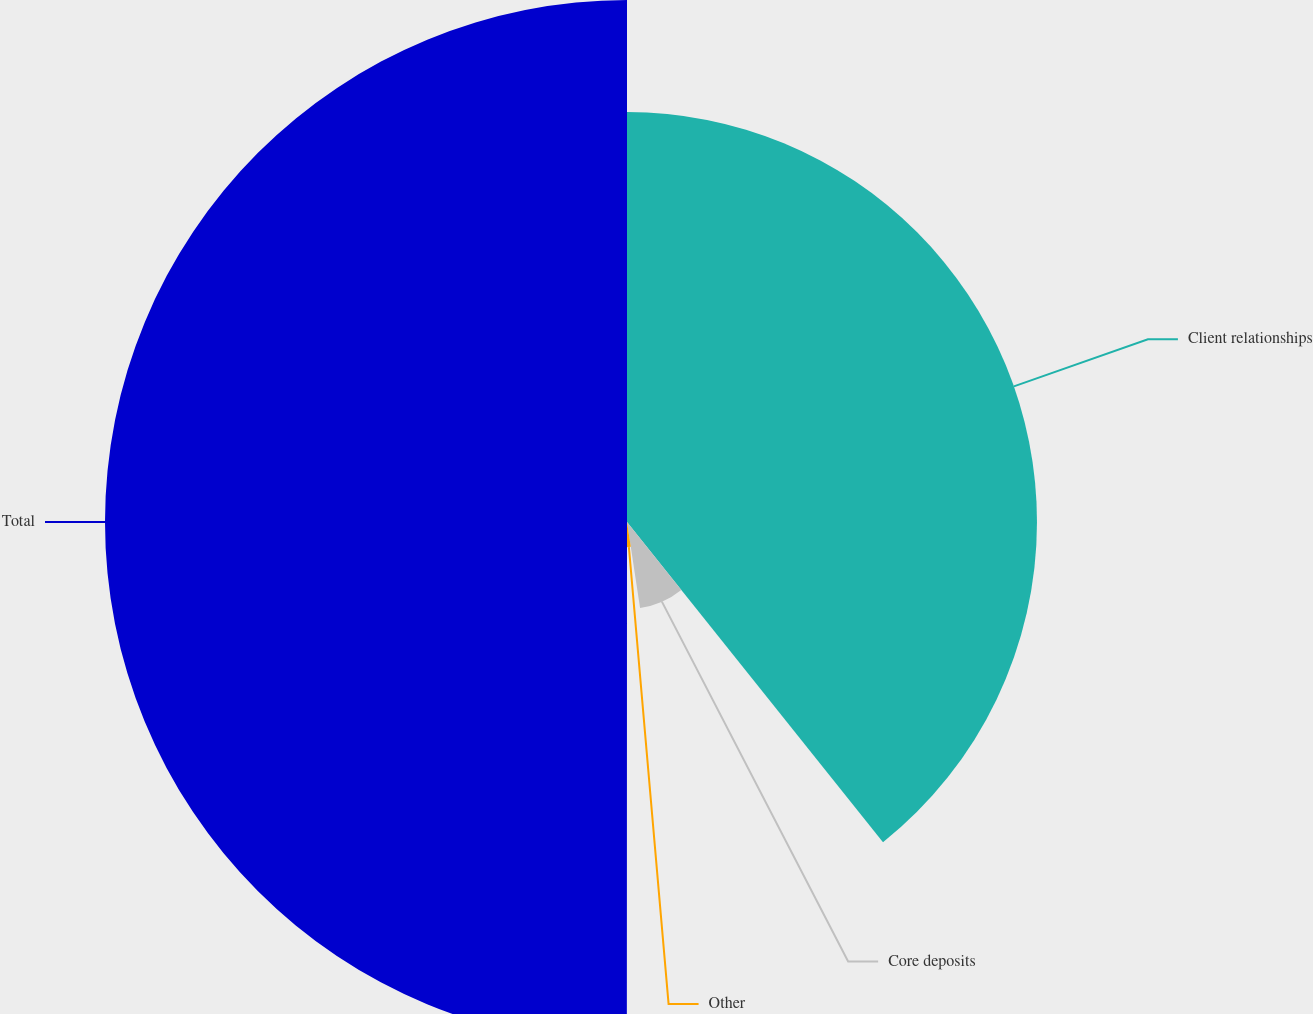<chart> <loc_0><loc_0><loc_500><loc_500><pie_chart><fcel>Client relationships<fcel>Core deposits<fcel>Other<fcel>Total<nl><fcel>39.27%<fcel>8.33%<fcel>2.41%<fcel>50.0%<nl></chart> 